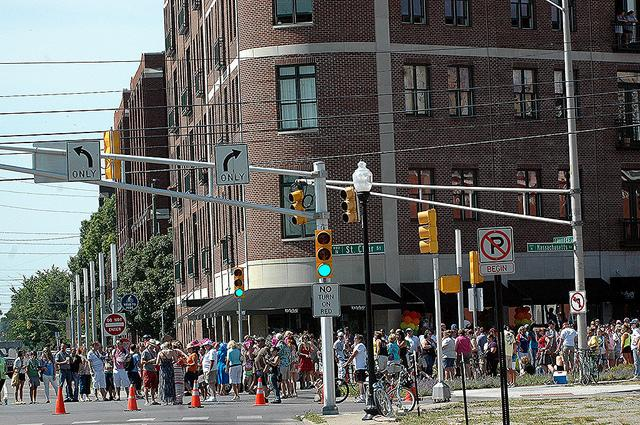Why are the traffic cones positioned in the location that they are?

Choices:
A) directions
B) road closure
C) art
D) construction road closure 